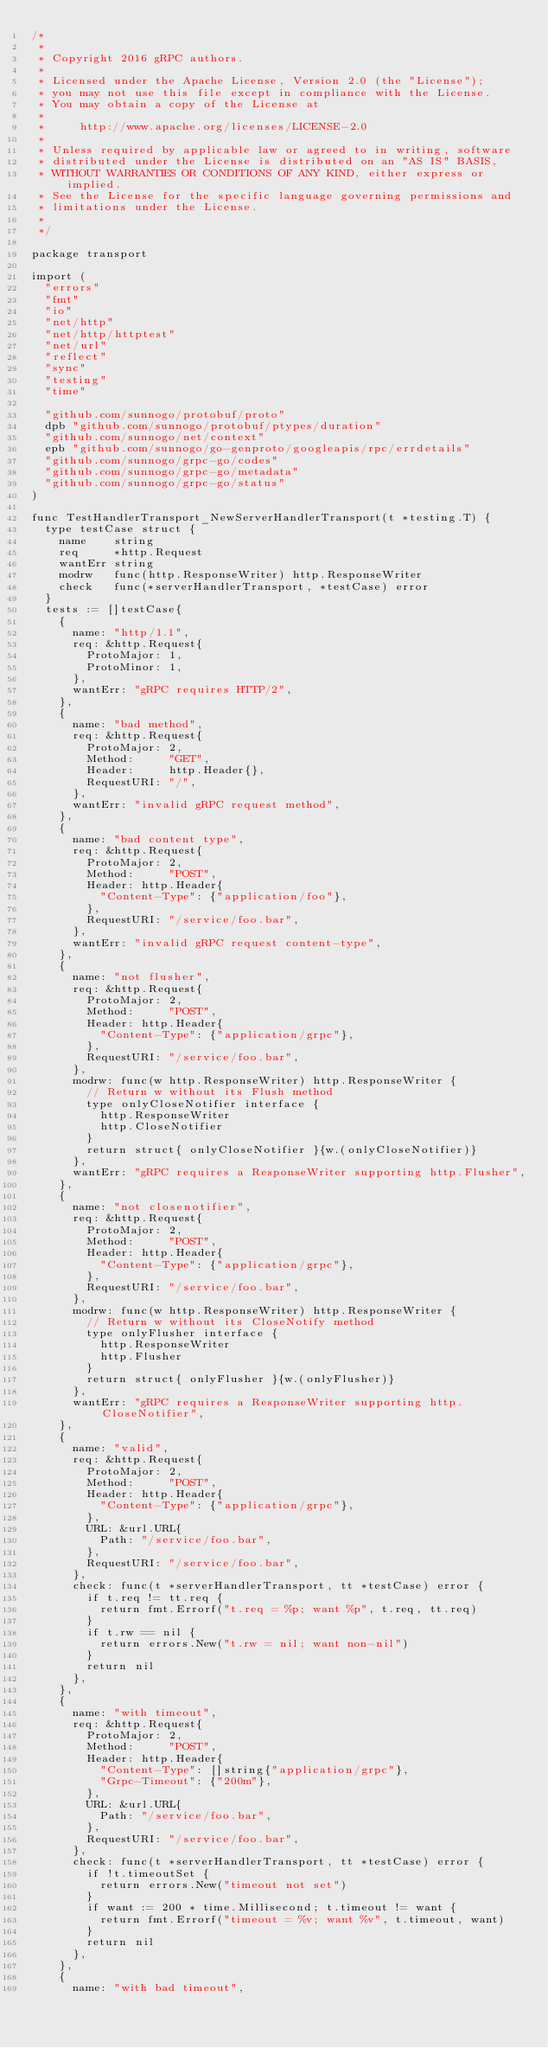Convert code to text. <code><loc_0><loc_0><loc_500><loc_500><_Go_>/*
 *
 * Copyright 2016 gRPC authors.
 *
 * Licensed under the Apache License, Version 2.0 (the "License");
 * you may not use this file except in compliance with the License.
 * You may obtain a copy of the License at
 *
 *     http://www.apache.org/licenses/LICENSE-2.0
 *
 * Unless required by applicable law or agreed to in writing, software
 * distributed under the License is distributed on an "AS IS" BASIS,
 * WITHOUT WARRANTIES OR CONDITIONS OF ANY KIND, either express or implied.
 * See the License for the specific language governing permissions and
 * limitations under the License.
 *
 */

package transport

import (
	"errors"
	"fmt"
	"io"
	"net/http"
	"net/http/httptest"
	"net/url"
	"reflect"
	"sync"
	"testing"
	"time"

	"github.com/sunnogo/protobuf/proto"
	dpb "github.com/sunnogo/protobuf/ptypes/duration"
	"github.com/sunnogo/net/context"
	epb "github.com/sunnogo/go-genproto/googleapis/rpc/errdetails"
	"github.com/sunnogo/grpc-go/codes"
	"github.com/sunnogo/grpc-go/metadata"
	"github.com/sunnogo/grpc-go/status"
)

func TestHandlerTransport_NewServerHandlerTransport(t *testing.T) {
	type testCase struct {
		name    string
		req     *http.Request
		wantErr string
		modrw   func(http.ResponseWriter) http.ResponseWriter
		check   func(*serverHandlerTransport, *testCase) error
	}
	tests := []testCase{
		{
			name: "http/1.1",
			req: &http.Request{
				ProtoMajor: 1,
				ProtoMinor: 1,
			},
			wantErr: "gRPC requires HTTP/2",
		},
		{
			name: "bad method",
			req: &http.Request{
				ProtoMajor: 2,
				Method:     "GET",
				Header:     http.Header{},
				RequestURI: "/",
			},
			wantErr: "invalid gRPC request method",
		},
		{
			name: "bad content type",
			req: &http.Request{
				ProtoMajor: 2,
				Method:     "POST",
				Header: http.Header{
					"Content-Type": {"application/foo"},
				},
				RequestURI: "/service/foo.bar",
			},
			wantErr: "invalid gRPC request content-type",
		},
		{
			name: "not flusher",
			req: &http.Request{
				ProtoMajor: 2,
				Method:     "POST",
				Header: http.Header{
					"Content-Type": {"application/grpc"},
				},
				RequestURI: "/service/foo.bar",
			},
			modrw: func(w http.ResponseWriter) http.ResponseWriter {
				// Return w without its Flush method
				type onlyCloseNotifier interface {
					http.ResponseWriter
					http.CloseNotifier
				}
				return struct{ onlyCloseNotifier }{w.(onlyCloseNotifier)}
			},
			wantErr: "gRPC requires a ResponseWriter supporting http.Flusher",
		},
		{
			name: "not closenotifier",
			req: &http.Request{
				ProtoMajor: 2,
				Method:     "POST",
				Header: http.Header{
					"Content-Type": {"application/grpc"},
				},
				RequestURI: "/service/foo.bar",
			},
			modrw: func(w http.ResponseWriter) http.ResponseWriter {
				// Return w without its CloseNotify method
				type onlyFlusher interface {
					http.ResponseWriter
					http.Flusher
				}
				return struct{ onlyFlusher }{w.(onlyFlusher)}
			},
			wantErr: "gRPC requires a ResponseWriter supporting http.CloseNotifier",
		},
		{
			name: "valid",
			req: &http.Request{
				ProtoMajor: 2,
				Method:     "POST",
				Header: http.Header{
					"Content-Type": {"application/grpc"},
				},
				URL: &url.URL{
					Path: "/service/foo.bar",
				},
				RequestURI: "/service/foo.bar",
			},
			check: func(t *serverHandlerTransport, tt *testCase) error {
				if t.req != tt.req {
					return fmt.Errorf("t.req = %p; want %p", t.req, tt.req)
				}
				if t.rw == nil {
					return errors.New("t.rw = nil; want non-nil")
				}
				return nil
			},
		},
		{
			name: "with timeout",
			req: &http.Request{
				ProtoMajor: 2,
				Method:     "POST",
				Header: http.Header{
					"Content-Type": []string{"application/grpc"},
					"Grpc-Timeout": {"200m"},
				},
				URL: &url.URL{
					Path: "/service/foo.bar",
				},
				RequestURI: "/service/foo.bar",
			},
			check: func(t *serverHandlerTransport, tt *testCase) error {
				if !t.timeoutSet {
					return errors.New("timeout not set")
				}
				if want := 200 * time.Millisecond; t.timeout != want {
					return fmt.Errorf("timeout = %v; want %v", t.timeout, want)
				}
				return nil
			},
		},
		{
			name: "with bad timeout",</code> 